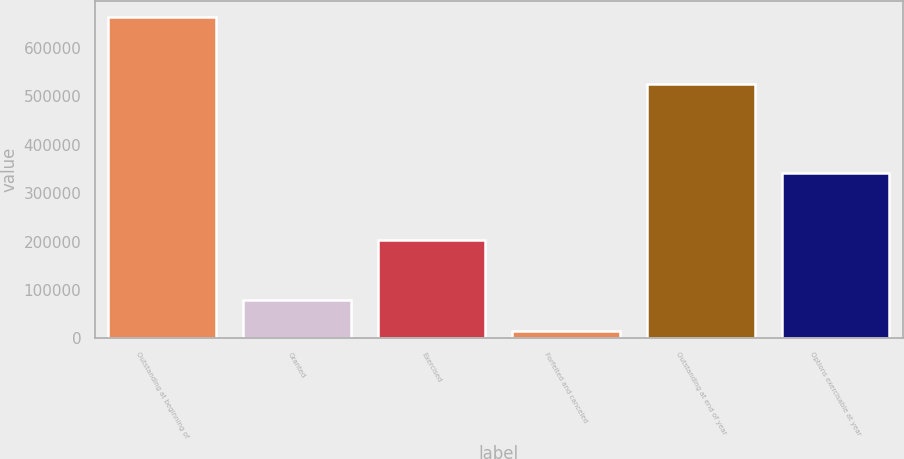Convert chart to OTSL. <chart><loc_0><loc_0><loc_500><loc_500><bar_chart><fcel>Outstanding at beginning of<fcel>Granted<fcel>Exercised<fcel>Forfeited and canceled<fcel>Outstanding at end of year<fcel>Options exercisable at year<nl><fcel>664785<fcel>79740<fcel>203556<fcel>14735<fcel>525094<fcel>342048<nl></chart> 